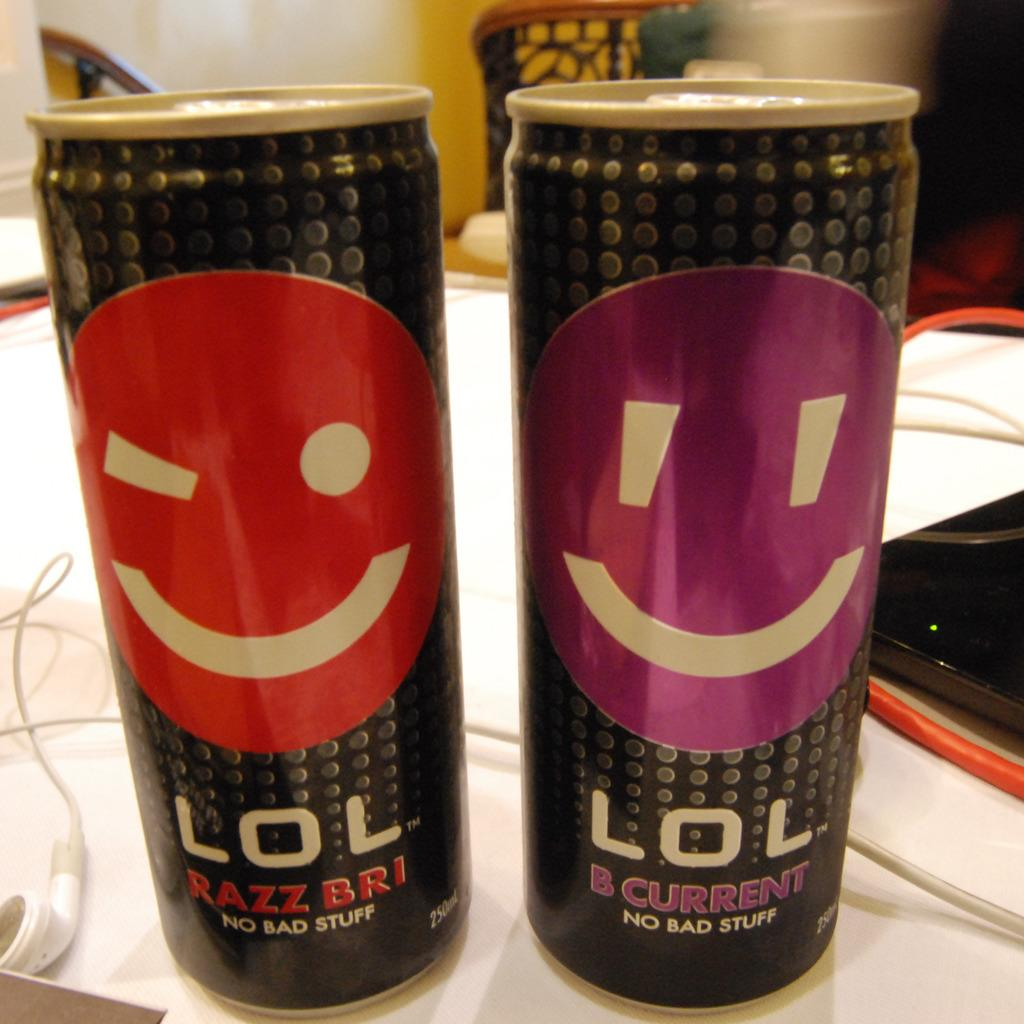Provide a one-sentence caption for the provided image. Two can of the drink LOL, one B current flavor and one Razz Bri flavor. 